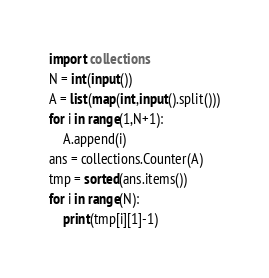Convert code to text. <code><loc_0><loc_0><loc_500><loc_500><_Python_>import collections
N = int(input())
A = list(map(int,input().split()))
for i in range(1,N+1):
    A.append(i)
ans = collections.Counter(A)
tmp = sorted(ans.items())
for i in range(N):
    print(tmp[i][1]-1)</code> 